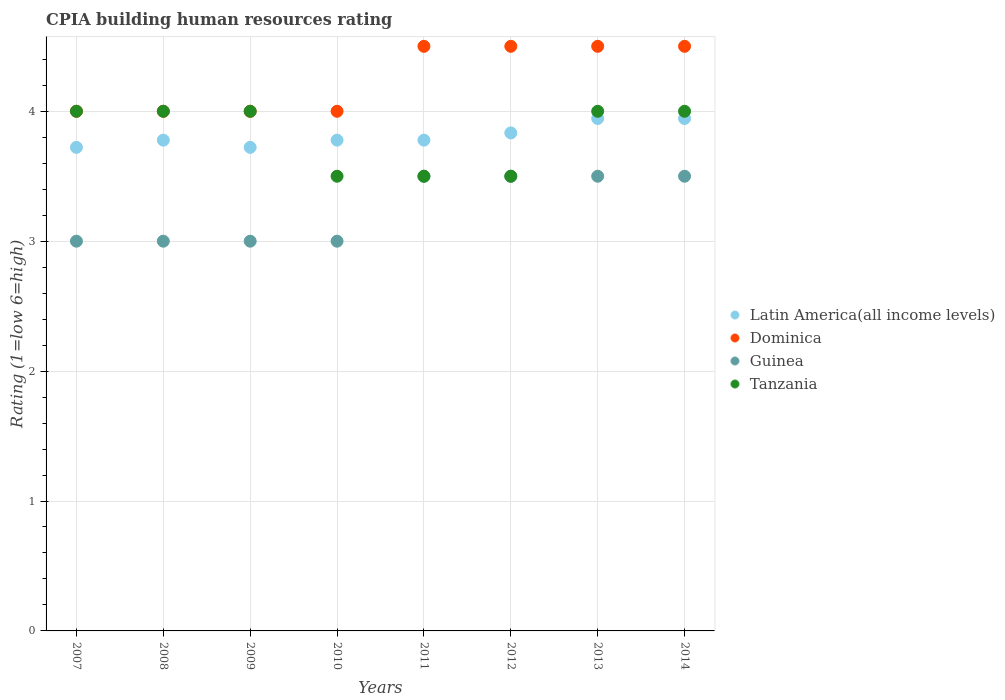How many different coloured dotlines are there?
Keep it short and to the point. 4. Is the number of dotlines equal to the number of legend labels?
Ensure brevity in your answer.  Yes. In which year was the CPIA rating in Tanzania maximum?
Your answer should be very brief. 2007. In which year was the CPIA rating in Tanzania minimum?
Your answer should be very brief. 2010. What is the total CPIA rating in Dominica in the graph?
Provide a succinct answer. 34. What is the difference between the CPIA rating in Dominica in 2008 and that in 2013?
Keep it short and to the point. -0.5. What is the difference between the CPIA rating in Latin America(all income levels) in 2014 and the CPIA rating in Guinea in 2007?
Offer a terse response. 0.94. What is the average CPIA rating in Dominica per year?
Make the answer very short. 4.25. In the year 2010, what is the difference between the CPIA rating in Tanzania and CPIA rating in Dominica?
Offer a very short reply. -0.5. In how many years, is the CPIA rating in Guinea greater than 1.2?
Your answer should be compact. 8. What is the ratio of the CPIA rating in Guinea in 2007 to that in 2014?
Make the answer very short. 0.86. Is the difference between the CPIA rating in Tanzania in 2010 and 2014 greater than the difference between the CPIA rating in Dominica in 2010 and 2014?
Ensure brevity in your answer.  No. What is the difference between the highest and the second highest CPIA rating in Dominica?
Offer a terse response. 0. What is the difference between the highest and the lowest CPIA rating in Guinea?
Keep it short and to the point. 0.5. In how many years, is the CPIA rating in Guinea greater than the average CPIA rating in Guinea taken over all years?
Your response must be concise. 4. Is the sum of the CPIA rating in Guinea in 2011 and 2014 greater than the maximum CPIA rating in Tanzania across all years?
Provide a succinct answer. Yes. Is it the case that in every year, the sum of the CPIA rating in Latin America(all income levels) and CPIA rating in Guinea  is greater than the sum of CPIA rating in Tanzania and CPIA rating in Dominica?
Your answer should be very brief. No. Is it the case that in every year, the sum of the CPIA rating in Latin America(all income levels) and CPIA rating in Dominica  is greater than the CPIA rating in Guinea?
Your answer should be compact. Yes. Does the CPIA rating in Guinea monotonically increase over the years?
Your answer should be very brief. No. Is the CPIA rating in Tanzania strictly greater than the CPIA rating in Latin America(all income levels) over the years?
Offer a terse response. No. Is the CPIA rating in Tanzania strictly less than the CPIA rating in Dominica over the years?
Offer a terse response. No. How many years are there in the graph?
Your answer should be compact. 8. Does the graph contain grids?
Offer a very short reply. Yes. How are the legend labels stacked?
Your response must be concise. Vertical. What is the title of the graph?
Your answer should be very brief. CPIA building human resources rating. Does "United States" appear as one of the legend labels in the graph?
Offer a terse response. No. What is the label or title of the Y-axis?
Provide a short and direct response. Rating (1=low 6=high). What is the Rating (1=low 6=high) of Latin America(all income levels) in 2007?
Your answer should be compact. 3.72. What is the Rating (1=low 6=high) in Dominica in 2007?
Provide a short and direct response. 4. What is the Rating (1=low 6=high) of Tanzania in 2007?
Ensure brevity in your answer.  4. What is the Rating (1=low 6=high) in Latin America(all income levels) in 2008?
Provide a short and direct response. 3.78. What is the Rating (1=low 6=high) in Latin America(all income levels) in 2009?
Your answer should be very brief. 3.72. What is the Rating (1=low 6=high) in Latin America(all income levels) in 2010?
Keep it short and to the point. 3.78. What is the Rating (1=low 6=high) of Guinea in 2010?
Give a very brief answer. 3. What is the Rating (1=low 6=high) in Tanzania in 2010?
Your answer should be very brief. 3.5. What is the Rating (1=low 6=high) of Latin America(all income levels) in 2011?
Keep it short and to the point. 3.78. What is the Rating (1=low 6=high) of Dominica in 2011?
Ensure brevity in your answer.  4.5. What is the Rating (1=low 6=high) in Guinea in 2011?
Provide a short and direct response. 3.5. What is the Rating (1=low 6=high) of Tanzania in 2011?
Give a very brief answer. 3.5. What is the Rating (1=low 6=high) of Latin America(all income levels) in 2012?
Give a very brief answer. 3.83. What is the Rating (1=low 6=high) of Dominica in 2012?
Your answer should be very brief. 4.5. What is the Rating (1=low 6=high) of Tanzania in 2012?
Ensure brevity in your answer.  3.5. What is the Rating (1=low 6=high) in Latin America(all income levels) in 2013?
Your response must be concise. 3.94. What is the Rating (1=low 6=high) of Dominica in 2013?
Offer a terse response. 4.5. What is the Rating (1=low 6=high) of Guinea in 2013?
Provide a short and direct response. 3.5. What is the Rating (1=low 6=high) in Latin America(all income levels) in 2014?
Offer a terse response. 3.94. What is the Rating (1=low 6=high) in Dominica in 2014?
Your answer should be compact. 4.5. What is the Rating (1=low 6=high) in Guinea in 2014?
Your answer should be very brief. 3.5. What is the Rating (1=low 6=high) in Tanzania in 2014?
Your answer should be very brief. 4. Across all years, what is the maximum Rating (1=low 6=high) in Latin America(all income levels)?
Your answer should be compact. 3.94. Across all years, what is the maximum Rating (1=low 6=high) in Dominica?
Your answer should be very brief. 4.5. Across all years, what is the maximum Rating (1=low 6=high) in Guinea?
Provide a succinct answer. 3.5. Across all years, what is the minimum Rating (1=low 6=high) of Latin America(all income levels)?
Your response must be concise. 3.72. Across all years, what is the minimum Rating (1=low 6=high) in Dominica?
Your response must be concise. 4. What is the total Rating (1=low 6=high) in Latin America(all income levels) in the graph?
Keep it short and to the point. 30.5. What is the total Rating (1=low 6=high) in Dominica in the graph?
Ensure brevity in your answer.  34. What is the total Rating (1=low 6=high) of Tanzania in the graph?
Provide a succinct answer. 30.5. What is the difference between the Rating (1=low 6=high) of Latin America(all income levels) in 2007 and that in 2008?
Your answer should be very brief. -0.06. What is the difference between the Rating (1=low 6=high) of Tanzania in 2007 and that in 2008?
Keep it short and to the point. 0. What is the difference between the Rating (1=low 6=high) in Dominica in 2007 and that in 2009?
Your response must be concise. 0. What is the difference between the Rating (1=low 6=high) in Guinea in 2007 and that in 2009?
Offer a terse response. 0. What is the difference between the Rating (1=low 6=high) in Tanzania in 2007 and that in 2009?
Offer a terse response. 0. What is the difference between the Rating (1=low 6=high) in Latin America(all income levels) in 2007 and that in 2010?
Provide a succinct answer. -0.06. What is the difference between the Rating (1=low 6=high) in Dominica in 2007 and that in 2010?
Your answer should be very brief. 0. What is the difference between the Rating (1=low 6=high) of Latin America(all income levels) in 2007 and that in 2011?
Give a very brief answer. -0.06. What is the difference between the Rating (1=low 6=high) in Guinea in 2007 and that in 2011?
Ensure brevity in your answer.  -0.5. What is the difference between the Rating (1=low 6=high) in Latin America(all income levels) in 2007 and that in 2012?
Your response must be concise. -0.11. What is the difference between the Rating (1=low 6=high) of Dominica in 2007 and that in 2012?
Give a very brief answer. -0.5. What is the difference between the Rating (1=low 6=high) in Latin America(all income levels) in 2007 and that in 2013?
Ensure brevity in your answer.  -0.22. What is the difference between the Rating (1=low 6=high) in Guinea in 2007 and that in 2013?
Offer a very short reply. -0.5. What is the difference between the Rating (1=low 6=high) in Tanzania in 2007 and that in 2013?
Ensure brevity in your answer.  0. What is the difference between the Rating (1=low 6=high) of Latin America(all income levels) in 2007 and that in 2014?
Keep it short and to the point. -0.22. What is the difference between the Rating (1=low 6=high) in Latin America(all income levels) in 2008 and that in 2009?
Provide a short and direct response. 0.06. What is the difference between the Rating (1=low 6=high) of Dominica in 2008 and that in 2009?
Offer a very short reply. 0. What is the difference between the Rating (1=low 6=high) in Guinea in 2008 and that in 2009?
Make the answer very short. 0. What is the difference between the Rating (1=low 6=high) in Tanzania in 2008 and that in 2009?
Offer a very short reply. 0. What is the difference between the Rating (1=low 6=high) in Latin America(all income levels) in 2008 and that in 2010?
Your answer should be very brief. 0. What is the difference between the Rating (1=low 6=high) of Guinea in 2008 and that in 2010?
Provide a short and direct response. 0. What is the difference between the Rating (1=low 6=high) of Latin America(all income levels) in 2008 and that in 2011?
Offer a terse response. 0. What is the difference between the Rating (1=low 6=high) of Dominica in 2008 and that in 2011?
Your answer should be compact. -0.5. What is the difference between the Rating (1=low 6=high) of Latin America(all income levels) in 2008 and that in 2012?
Your answer should be very brief. -0.06. What is the difference between the Rating (1=low 6=high) of Dominica in 2008 and that in 2012?
Provide a short and direct response. -0.5. What is the difference between the Rating (1=low 6=high) in Latin America(all income levels) in 2008 and that in 2013?
Offer a terse response. -0.17. What is the difference between the Rating (1=low 6=high) of Tanzania in 2008 and that in 2013?
Offer a very short reply. 0. What is the difference between the Rating (1=low 6=high) of Latin America(all income levels) in 2008 and that in 2014?
Make the answer very short. -0.17. What is the difference between the Rating (1=low 6=high) of Guinea in 2008 and that in 2014?
Provide a succinct answer. -0.5. What is the difference between the Rating (1=low 6=high) of Latin America(all income levels) in 2009 and that in 2010?
Provide a short and direct response. -0.06. What is the difference between the Rating (1=low 6=high) in Dominica in 2009 and that in 2010?
Provide a short and direct response. 0. What is the difference between the Rating (1=low 6=high) of Guinea in 2009 and that in 2010?
Your answer should be compact. 0. What is the difference between the Rating (1=low 6=high) of Tanzania in 2009 and that in 2010?
Keep it short and to the point. 0.5. What is the difference between the Rating (1=low 6=high) of Latin America(all income levels) in 2009 and that in 2011?
Give a very brief answer. -0.06. What is the difference between the Rating (1=low 6=high) of Guinea in 2009 and that in 2011?
Offer a terse response. -0.5. What is the difference between the Rating (1=low 6=high) of Tanzania in 2009 and that in 2011?
Offer a terse response. 0.5. What is the difference between the Rating (1=low 6=high) of Latin America(all income levels) in 2009 and that in 2012?
Provide a short and direct response. -0.11. What is the difference between the Rating (1=low 6=high) of Tanzania in 2009 and that in 2012?
Provide a short and direct response. 0.5. What is the difference between the Rating (1=low 6=high) of Latin America(all income levels) in 2009 and that in 2013?
Provide a succinct answer. -0.22. What is the difference between the Rating (1=low 6=high) in Latin America(all income levels) in 2009 and that in 2014?
Provide a succinct answer. -0.22. What is the difference between the Rating (1=low 6=high) in Dominica in 2009 and that in 2014?
Your answer should be compact. -0.5. What is the difference between the Rating (1=low 6=high) in Latin America(all income levels) in 2010 and that in 2011?
Offer a terse response. 0. What is the difference between the Rating (1=low 6=high) in Guinea in 2010 and that in 2011?
Give a very brief answer. -0.5. What is the difference between the Rating (1=low 6=high) of Latin America(all income levels) in 2010 and that in 2012?
Provide a succinct answer. -0.06. What is the difference between the Rating (1=low 6=high) of Guinea in 2010 and that in 2012?
Your answer should be very brief. -0.5. What is the difference between the Rating (1=low 6=high) of Tanzania in 2010 and that in 2012?
Ensure brevity in your answer.  0. What is the difference between the Rating (1=low 6=high) of Latin America(all income levels) in 2010 and that in 2013?
Give a very brief answer. -0.17. What is the difference between the Rating (1=low 6=high) in Guinea in 2010 and that in 2013?
Your answer should be compact. -0.5. What is the difference between the Rating (1=low 6=high) of Tanzania in 2010 and that in 2014?
Make the answer very short. -0.5. What is the difference between the Rating (1=low 6=high) of Latin America(all income levels) in 2011 and that in 2012?
Provide a succinct answer. -0.06. What is the difference between the Rating (1=low 6=high) of Guinea in 2011 and that in 2012?
Offer a terse response. 0. What is the difference between the Rating (1=low 6=high) in Latin America(all income levels) in 2011 and that in 2013?
Offer a terse response. -0.17. What is the difference between the Rating (1=low 6=high) of Guinea in 2011 and that in 2013?
Your answer should be compact. 0. What is the difference between the Rating (1=low 6=high) of Latin America(all income levels) in 2011 and that in 2014?
Provide a succinct answer. -0.17. What is the difference between the Rating (1=low 6=high) of Dominica in 2011 and that in 2014?
Give a very brief answer. 0. What is the difference between the Rating (1=low 6=high) in Guinea in 2011 and that in 2014?
Provide a succinct answer. 0. What is the difference between the Rating (1=low 6=high) of Tanzania in 2011 and that in 2014?
Keep it short and to the point. -0.5. What is the difference between the Rating (1=low 6=high) of Latin America(all income levels) in 2012 and that in 2013?
Provide a succinct answer. -0.11. What is the difference between the Rating (1=low 6=high) of Tanzania in 2012 and that in 2013?
Make the answer very short. -0.5. What is the difference between the Rating (1=low 6=high) of Latin America(all income levels) in 2012 and that in 2014?
Your response must be concise. -0.11. What is the difference between the Rating (1=low 6=high) in Guinea in 2012 and that in 2014?
Your response must be concise. 0. What is the difference between the Rating (1=low 6=high) of Latin America(all income levels) in 2007 and the Rating (1=low 6=high) of Dominica in 2008?
Offer a very short reply. -0.28. What is the difference between the Rating (1=low 6=high) in Latin America(all income levels) in 2007 and the Rating (1=low 6=high) in Guinea in 2008?
Provide a succinct answer. 0.72. What is the difference between the Rating (1=low 6=high) of Latin America(all income levels) in 2007 and the Rating (1=low 6=high) of Tanzania in 2008?
Give a very brief answer. -0.28. What is the difference between the Rating (1=low 6=high) in Dominica in 2007 and the Rating (1=low 6=high) in Guinea in 2008?
Your response must be concise. 1. What is the difference between the Rating (1=low 6=high) in Dominica in 2007 and the Rating (1=low 6=high) in Tanzania in 2008?
Offer a very short reply. 0. What is the difference between the Rating (1=low 6=high) in Latin America(all income levels) in 2007 and the Rating (1=low 6=high) in Dominica in 2009?
Keep it short and to the point. -0.28. What is the difference between the Rating (1=low 6=high) of Latin America(all income levels) in 2007 and the Rating (1=low 6=high) of Guinea in 2009?
Provide a succinct answer. 0.72. What is the difference between the Rating (1=low 6=high) of Latin America(all income levels) in 2007 and the Rating (1=low 6=high) of Tanzania in 2009?
Offer a very short reply. -0.28. What is the difference between the Rating (1=low 6=high) in Dominica in 2007 and the Rating (1=low 6=high) in Tanzania in 2009?
Offer a very short reply. 0. What is the difference between the Rating (1=low 6=high) of Guinea in 2007 and the Rating (1=low 6=high) of Tanzania in 2009?
Keep it short and to the point. -1. What is the difference between the Rating (1=low 6=high) of Latin America(all income levels) in 2007 and the Rating (1=low 6=high) of Dominica in 2010?
Make the answer very short. -0.28. What is the difference between the Rating (1=low 6=high) of Latin America(all income levels) in 2007 and the Rating (1=low 6=high) of Guinea in 2010?
Ensure brevity in your answer.  0.72. What is the difference between the Rating (1=low 6=high) in Latin America(all income levels) in 2007 and the Rating (1=low 6=high) in Tanzania in 2010?
Give a very brief answer. 0.22. What is the difference between the Rating (1=low 6=high) in Dominica in 2007 and the Rating (1=low 6=high) in Tanzania in 2010?
Your answer should be very brief. 0.5. What is the difference between the Rating (1=low 6=high) in Guinea in 2007 and the Rating (1=low 6=high) in Tanzania in 2010?
Keep it short and to the point. -0.5. What is the difference between the Rating (1=low 6=high) in Latin America(all income levels) in 2007 and the Rating (1=low 6=high) in Dominica in 2011?
Keep it short and to the point. -0.78. What is the difference between the Rating (1=low 6=high) of Latin America(all income levels) in 2007 and the Rating (1=low 6=high) of Guinea in 2011?
Your answer should be compact. 0.22. What is the difference between the Rating (1=low 6=high) in Latin America(all income levels) in 2007 and the Rating (1=low 6=high) in Tanzania in 2011?
Provide a succinct answer. 0.22. What is the difference between the Rating (1=low 6=high) in Dominica in 2007 and the Rating (1=low 6=high) in Guinea in 2011?
Keep it short and to the point. 0.5. What is the difference between the Rating (1=low 6=high) in Guinea in 2007 and the Rating (1=low 6=high) in Tanzania in 2011?
Provide a succinct answer. -0.5. What is the difference between the Rating (1=low 6=high) of Latin America(all income levels) in 2007 and the Rating (1=low 6=high) of Dominica in 2012?
Make the answer very short. -0.78. What is the difference between the Rating (1=low 6=high) of Latin America(all income levels) in 2007 and the Rating (1=low 6=high) of Guinea in 2012?
Your answer should be compact. 0.22. What is the difference between the Rating (1=low 6=high) of Latin America(all income levels) in 2007 and the Rating (1=low 6=high) of Tanzania in 2012?
Your answer should be very brief. 0.22. What is the difference between the Rating (1=low 6=high) of Dominica in 2007 and the Rating (1=low 6=high) of Tanzania in 2012?
Make the answer very short. 0.5. What is the difference between the Rating (1=low 6=high) in Guinea in 2007 and the Rating (1=low 6=high) in Tanzania in 2012?
Your answer should be compact. -0.5. What is the difference between the Rating (1=low 6=high) in Latin America(all income levels) in 2007 and the Rating (1=low 6=high) in Dominica in 2013?
Your answer should be compact. -0.78. What is the difference between the Rating (1=low 6=high) in Latin America(all income levels) in 2007 and the Rating (1=low 6=high) in Guinea in 2013?
Offer a terse response. 0.22. What is the difference between the Rating (1=low 6=high) of Latin America(all income levels) in 2007 and the Rating (1=low 6=high) of Tanzania in 2013?
Give a very brief answer. -0.28. What is the difference between the Rating (1=low 6=high) in Dominica in 2007 and the Rating (1=low 6=high) in Tanzania in 2013?
Keep it short and to the point. 0. What is the difference between the Rating (1=low 6=high) of Latin America(all income levels) in 2007 and the Rating (1=low 6=high) of Dominica in 2014?
Offer a terse response. -0.78. What is the difference between the Rating (1=low 6=high) in Latin America(all income levels) in 2007 and the Rating (1=low 6=high) in Guinea in 2014?
Your answer should be very brief. 0.22. What is the difference between the Rating (1=low 6=high) of Latin America(all income levels) in 2007 and the Rating (1=low 6=high) of Tanzania in 2014?
Provide a succinct answer. -0.28. What is the difference between the Rating (1=low 6=high) in Guinea in 2007 and the Rating (1=low 6=high) in Tanzania in 2014?
Offer a very short reply. -1. What is the difference between the Rating (1=low 6=high) in Latin America(all income levels) in 2008 and the Rating (1=low 6=high) in Dominica in 2009?
Give a very brief answer. -0.22. What is the difference between the Rating (1=low 6=high) of Latin America(all income levels) in 2008 and the Rating (1=low 6=high) of Tanzania in 2009?
Provide a short and direct response. -0.22. What is the difference between the Rating (1=low 6=high) of Dominica in 2008 and the Rating (1=low 6=high) of Guinea in 2009?
Your response must be concise. 1. What is the difference between the Rating (1=low 6=high) of Guinea in 2008 and the Rating (1=low 6=high) of Tanzania in 2009?
Provide a succinct answer. -1. What is the difference between the Rating (1=low 6=high) of Latin America(all income levels) in 2008 and the Rating (1=low 6=high) of Dominica in 2010?
Offer a very short reply. -0.22. What is the difference between the Rating (1=low 6=high) in Latin America(all income levels) in 2008 and the Rating (1=low 6=high) in Tanzania in 2010?
Ensure brevity in your answer.  0.28. What is the difference between the Rating (1=low 6=high) of Guinea in 2008 and the Rating (1=low 6=high) of Tanzania in 2010?
Keep it short and to the point. -0.5. What is the difference between the Rating (1=low 6=high) in Latin America(all income levels) in 2008 and the Rating (1=low 6=high) in Dominica in 2011?
Make the answer very short. -0.72. What is the difference between the Rating (1=low 6=high) of Latin America(all income levels) in 2008 and the Rating (1=low 6=high) of Guinea in 2011?
Make the answer very short. 0.28. What is the difference between the Rating (1=low 6=high) in Latin America(all income levels) in 2008 and the Rating (1=low 6=high) in Tanzania in 2011?
Your answer should be very brief. 0.28. What is the difference between the Rating (1=low 6=high) of Latin America(all income levels) in 2008 and the Rating (1=low 6=high) of Dominica in 2012?
Ensure brevity in your answer.  -0.72. What is the difference between the Rating (1=low 6=high) in Latin America(all income levels) in 2008 and the Rating (1=low 6=high) in Guinea in 2012?
Keep it short and to the point. 0.28. What is the difference between the Rating (1=low 6=high) in Latin America(all income levels) in 2008 and the Rating (1=low 6=high) in Tanzania in 2012?
Provide a succinct answer. 0.28. What is the difference between the Rating (1=low 6=high) in Dominica in 2008 and the Rating (1=low 6=high) in Guinea in 2012?
Offer a terse response. 0.5. What is the difference between the Rating (1=low 6=high) of Latin America(all income levels) in 2008 and the Rating (1=low 6=high) of Dominica in 2013?
Provide a short and direct response. -0.72. What is the difference between the Rating (1=low 6=high) in Latin America(all income levels) in 2008 and the Rating (1=low 6=high) in Guinea in 2013?
Offer a terse response. 0.28. What is the difference between the Rating (1=low 6=high) in Latin America(all income levels) in 2008 and the Rating (1=low 6=high) in Tanzania in 2013?
Ensure brevity in your answer.  -0.22. What is the difference between the Rating (1=low 6=high) in Dominica in 2008 and the Rating (1=low 6=high) in Tanzania in 2013?
Offer a terse response. 0. What is the difference between the Rating (1=low 6=high) of Guinea in 2008 and the Rating (1=low 6=high) of Tanzania in 2013?
Your answer should be compact. -1. What is the difference between the Rating (1=low 6=high) in Latin America(all income levels) in 2008 and the Rating (1=low 6=high) in Dominica in 2014?
Make the answer very short. -0.72. What is the difference between the Rating (1=low 6=high) of Latin America(all income levels) in 2008 and the Rating (1=low 6=high) of Guinea in 2014?
Your answer should be very brief. 0.28. What is the difference between the Rating (1=low 6=high) in Latin America(all income levels) in 2008 and the Rating (1=low 6=high) in Tanzania in 2014?
Your answer should be compact. -0.22. What is the difference between the Rating (1=low 6=high) of Dominica in 2008 and the Rating (1=low 6=high) of Tanzania in 2014?
Your answer should be very brief. 0. What is the difference between the Rating (1=low 6=high) of Latin America(all income levels) in 2009 and the Rating (1=low 6=high) of Dominica in 2010?
Provide a succinct answer. -0.28. What is the difference between the Rating (1=low 6=high) of Latin America(all income levels) in 2009 and the Rating (1=low 6=high) of Guinea in 2010?
Ensure brevity in your answer.  0.72. What is the difference between the Rating (1=low 6=high) of Latin America(all income levels) in 2009 and the Rating (1=low 6=high) of Tanzania in 2010?
Give a very brief answer. 0.22. What is the difference between the Rating (1=low 6=high) in Dominica in 2009 and the Rating (1=low 6=high) in Guinea in 2010?
Provide a succinct answer. 1. What is the difference between the Rating (1=low 6=high) of Guinea in 2009 and the Rating (1=low 6=high) of Tanzania in 2010?
Your response must be concise. -0.5. What is the difference between the Rating (1=low 6=high) in Latin America(all income levels) in 2009 and the Rating (1=low 6=high) in Dominica in 2011?
Offer a very short reply. -0.78. What is the difference between the Rating (1=low 6=high) in Latin America(all income levels) in 2009 and the Rating (1=low 6=high) in Guinea in 2011?
Make the answer very short. 0.22. What is the difference between the Rating (1=low 6=high) of Latin America(all income levels) in 2009 and the Rating (1=low 6=high) of Tanzania in 2011?
Provide a short and direct response. 0.22. What is the difference between the Rating (1=low 6=high) in Dominica in 2009 and the Rating (1=low 6=high) in Guinea in 2011?
Give a very brief answer. 0.5. What is the difference between the Rating (1=low 6=high) of Guinea in 2009 and the Rating (1=low 6=high) of Tanzania in 2011?
Make the answer very short. -0.5. What is the difference between the Rating (1=low 6=high) in Latin America(all income levels) in 2009 and the Rating (1=low 6=high) in Dominica in 2012?
Give a very brief answer. -0.78. What is the difference between the Rating (1=low 6=high) in Latin America(all income levels) in 2009 and the Rating (1=low 6=high) in Guinea in 2012?
Make the answer very short. 0.22. What is the difference between the Rating (1=low 6=high) of Latin America(all income levels) in 2009 and the Rating (1=low 6=high) of Tanzania in 2012?
Offer a terse response. 0.22. What is the difference between the Rating (1=low 6=high) of Dominica in 2009 and the Rating (1=low 6=high) of Guinea in 2012?
Provide a succinct answer. 0.5. What is the difference between the Rating (1=low 6=high) in Latin America(all income levels) in 2009 and the Rating (1=low 6=high) in Dominica in 2013?
Keep it short and to the point. -0.78. What is the difference between the Rating (1=low 6=high) of Latin America(all income levels) in 2009 and the Rating (1=low 6=high) of Guinea in 2013?
Give a very brief answer. 0.22. What is the difference between the Rating (1=low 6=high) in Latin America(all income levels) in 2009 and the Rating (1=low 6=high) in Tanzania in 2013?
Keep it short and to the point. -0.28. What is the difference between the Rating (1=low 6=high) in Dominica in 2009 and the Rating (1=low 6=high) in Guinea in 2013?
Ensure brevity in your answer.  0.5. What is the difference between the Rating (1=low 6=high) in Dominica in 2009 and the Rating (1=low 6=high) in Tanzania in 2013?
Make the answer very short. 0. What is the difference between the Rating (1=low 6=high) in Latin America(all income levels) in 2009 and the Rating (1=low 6=high) in Dominica in 2014?
Provide a succinct answer. -0.78. What is the difference between the Rating (1=low 6=high) in Latin America(all income levels) in 2009 and the Rating (1=low 6=high) in Guinea in 2014?
Ensure brevity in your answer.  0.22. What is the difference between the Rating (1=low 6=high) in Latin America(all income levels) in 2009 and the Rating (1=low 6=high) in Tanzania in 2014?
Provide a succinct answer. -0.28. What is the difference between the Rating (1=low 6=high) of Dominica in 2009 and the Rating (1=low 6=high) of Guinea in 2014?
Keep it short and to the point. 0.5. What is the difference between the Rating (1=low 6=high) of Dominica in 2009 and the Rating (1=low 6=high) of Tanzania in 2014?
Provide a succinct answer. 0. What is the difference between the Rating (1=low 6=high) in Guinea in 2009 and the Rating (1=low 6=high) in Tanzania in 2014?
Provide a succinct answer. -1. What is the difference between the Rating (1=low 6=high) in Latin America(all income levels) in 2010 and the Rating (1=low 6=high) in Dominica in 2011?
Offer a very short reply. -0.72. What is the difference between the Rating (1=low 6=high) in Latin America(all income levels) in 2010 and the Rating (1=low 6=high) in Guinea in 2011?
Provide a short and direct response. 0.28. What is the difference between the Rating (1=low 6=high) in Latin America(all income levels) in 2010 and the Rating (1=low 6=high) in Tanzania in 2011?
Your answer should be compact. 0.28. What is the difference between the Rating (1=low 6=high) of Dominica in 2010 and the Rating (1=low 6=high) of Tanzania in 2011?
Make the answer very short. 0.5. What is the difference between the Rating (1=low 6=high) in Latin America(all income levels) in 2010 and the Rating (1=low 6=high) in Dominica in 2012?
Provide a succinct answer. -0.72. What is the difference between the Rating (1=low 6=high) in Latin America(all income levels) in 2010 and the Rating (1=low 6=high) in Guinea in 2012?
Ensure brevity in your answer.  0.28. What is the difference between the Rating (1=low 6=high) in Latin America(all income levels) in 2010 and the Rating (1=low 6=high) in Tanzania in 2012?
Your answer should be compact. 0.28. What is the difference between the Rating (1=low 6=high) of Guinea in 2010 and the Rating (1=low 6=high) of Tanzania in 2012?
Your response must be concise. -0.5. What is the difference between the Rating (1=low 6=high) in Latin America(all income levels) in 2010 and the Rating (1=low 6=high) in Dominica in 2013?
Keep it short and to the point. -0.72. What is the difference between the Rating (1=low 6=high) in Latin America(all income levels) in 2010 and the Rating (1=low 6=high) in Guinea in 2013?
Provide a succinct answer. 0.28. What is the difference between the Rating (1=low 6=high) of Latin America(all income levels) in 2010 and the Rating (1=low 6=high) of Tanzania in 2013?
Provide a succinct answer. -0.22. What is the difference between the Rating (1=low 6=high) in Dominica in 2010 and the Rating (1=low 6=high) in Guinea in 2013?
Your response must be concise. 0.5. What is the difference between the Rating (1=low 6=high) in Dominica in 2010 and the Rating (1=low 6=high) in Tanzania in 2013?
Offer a terse response. 0. What is the difference between the Rating (1=low 6=high) in Guinea in 2010 and the Rating (1=low 6=high) in Tanzania in 2013?
Ensure brevity in your answer.  -1. What is the difference between the Rating (1=low 6=high) in Latin America(all income levels) in 2010 and the Rating (1=low 6=high) in Dominica in 2014?
Provide a succinct answer. -0.72. What is the difference between the Rating (1=low 6=high) of Latin America(all income levels) in 2010 and the Rating (1=low 6=high) of Guinea in 2014?
Keep it short and to the point. 0.28. What is the difference between the Rating (1=low 6=high) of Latin America(all income levels) in 2010 and the Rating (1=low 6=high) of Tanzania in 2014?
Provide a short and direct response. -0.22. What is the difference between the Rating (1=low 6=high) of Dominica in 2010 and the Rating (1=low 6=high) of Tanzania in 2014?
Keep it short and to the point. 0. What is the difference between the Rating (1=low 6=high) in Latin America(all income levels) in 2011 and the Rating (1=low 6=high) in Dominica in 2012?
Your answer should be very brief. -0.72. What is the difference between the Rating (1=low 6=high) in Latin America(all income levels) in 2011 and the Rating (1=low 6=high) in Guinea in 2012?
Make the answer very short. 0.28. What is the difference between the Rating (1=low 6=high) in Latin America(all income levels) in 2011 and the Rating (1=low 6=high) in Tanzania in 2012?
Provide a succinct answer. 0.28. What is the difference between the Rating (1=low 6=high) in Dominica in 2011 and the Rating (1=low 6=high) in Guinea in 2012?
Your answer should be compact. 1. What is the difference between the Rating (1=low 6=high) of Dominica in 2011 and the Rating (1=low 6=high) of Tanzania in 2012?
Offer a very short reply. 1. What is the difference between the Rating (1=low 6=high) in Guinea in 2011 and the Rating (1=low 6=high) in Tanzania in 2012?
Offer a very short reply. 0. What is the difference between the Rating (1=low 6=high) in Latin America(all income levels) in 2011 and the Rating (1=low 6=high) in Dominica in 2013?
Make the answer very short. -0.72. What is the difference between the Rating (1=low 6=high) in Latin America(all income levels) in 2011 and the Rating (1=low 6=high) in Guinea in 2013?
Your answer should be compact. 0.28. What is the difference between the Rating (1=low 6=high) of Latin America(all income levels) in 2011 and the Rating (1=low 6=high) of Tanzania in 2013?
Your answer should be compact. -0.22. What is the difference between the Rating (1=low 6=high) in Guinea in 2011 and the Rating (1=low 6=high) in Tanzania in 2013?
Provide a succinct answer. -0.5. What is the difference between the Rating (1=low 6=high) of Latin America(all income levels) in 2011 and the Rating (1=low 6=high) of Dominica in 2014?
Make the answer very short. -0.72. What is the difference between the Rating (1=low 6=high) of Latin America(all income levels) in 2011 and the Rating (1=low 6=high) of Guinea in 2014?
Offer a very short reply. 0.28. What is the difference between the Rating (1=low 6=high) of Latin America(all income levels) in 2011 and the Rating (1=low 6=high) of Tanzania in 2014?
Offer a very short reply. -0.22. What is the difference between the Rating (1=low 6=high) in Latin America(all income levels) in 2012 and the Rating (1=low 6=high) in Dominica in 2013?
Your answer should be very brief. -0.67. What is the difference between the Rating (1=low 6=high) in Latin America(all income levels) in 2012 and the Rating (1=low 6=high) in Guinea in 2013?
Make the answer very short. 0.33. What is the difference between the Rating (1=low 6=high) of Dominica in 2012 and the Rating (1=low 6=high) of Tanzania in 2013?
Your answer should be very brief. 0.5. What is the difference between the Rating (1=low 6=high) of Latin America(all income levels) in 2012 and the Rating (1=low 6=high) of Tanzania in 2014?
Provide a short and direct response. -0.17. What is the difference between the Rating (1=low 6=high) in Dominica in 2012 and the Rating (1=low 6=high) in Guinea in 2014?
Give a very brief answer. 1. What is the difference between the Rating (1=low 6=high) in Dominica in 2012 and the Rating (1=low 6=high) in Tanzania in 2014?
Your response must be concise. 0.5. What is the difference between the Rating (1=low 6=high) in Guinea in 2012 and the Rating (1=low 6=high) in Tanzania in 2014?
Offer a very short reply. -0.5. What is the difference between the Rating (1=low 6=high) in Latin America(all income levels) in 2013 and the Rating (1=low 6=high) in Dominica in 2014?
Your response must be concise. -0.56. What is the difference between the Rating (1=low 6=high) of Latin America(all income levels) in 2013 and the Rating (1=low 6=high) of Guinea in 2014?
Offer a very short reply. 0.44. What is the difference between the Rating (1=low 6=high) of Latin America(all income levels) in 2013 and the Rating (1=low 6=high) of Tanzania in 2014?
Keep it short and to the point. -0.06. What is the difference between the Rating (1=low 6=high) of Dominica in 2013 and the Rating (1=low 6=high) of Tanzania in 2014?
Offer a terse response. 0.5. What is the average Rating (1=low 6=high) in Latin America(all income levels) per year?
Provide a succinct answer. 3.81. What is the average Rating (1=low 6=high) of Dominica per year?
Give a very brief answer. 4.25. What is the average Rating (1=low 6=high) in Guinea per year?
Your answer should be very brief. 3.25. What is the average Rating (1=low 6=high) of Tanzania per year?
Keep it short and to the point. 3.81. In the year 2007, what is the difference between the Rating (1=low 6=high) of Latin America(all income levels) and Rating (1=low 6=high) of Dominica?
Your answer should be very brief. -0.28. In the year 2007, what is the difference between the Rating (1=low 6=high) of Latin America(all income levels) and Rating (1=low 6=high) of Guinea?
Keep it short and to the point. 0.72. In the year 2007, what is the difference between the Rating (1=low 6=high) in Latin America(all income levels) and Rating (1=low 6=high) in Tanzania?
Your answer should be compact. -0.28. In the year 2007, what is the difference between the Rating (1=low 6=high) of Dominica and Rating (1=low 6=high) of Guinea?
Provide a succinct answer. 1. In the year 2008, what is the difference between the Rating (1=low 6=high) in Latin America(all income levels) and Rating (1=low 6=high) in Dominica?
Your answer should be very brief. -0.22. In the year 2008, what is the difference between the Rating (1=low 6=high) in Latin America(all income levels) and Rating (1=low 6=high) in Tanzania?
Your answer should be very brief. -0.22. In the year 2008, what is the difference between the Rating (1=low 6=high) in Dominica and Rating (1=low 6=high) in Tanzania?
Provide a short and direct response. 0. In the year 2009, what is the difference between the Rating (1=low 6=high) in Latin America(all income levels) and Rating (1=low 6=high) in Dominica?
Your answer should be very brief. -0.28. In the year 2009, what is the difference between the Rating (1=low 6=high) in Latin America(all income levels) and Rating (1=low 6=high) in Guinea?
Offer a terse response. 0.72. In the year 2009, what is the difference between the Rating (1=low 6=high) of Latin America(all income levels) and Rating (1=low 6=high) of Tanzania?
Your answer should be very brief. -0.28. In the year 2009, what is the difference between the Rating (1=low 6=high) of Dominica and Rating (1=low 6=high) of Guinea?
Provide a short and direct response. 1. In the year 2009, what is the difference between the Rating (1=low 6=high) of Guinea and Rating (1=low 6=high) of Tanzania?
Ensure brevity in your answer.  -1. In the year 2010, what is the difference between the Rating (1=low 6=high) of Latin America(all income levels) and Rating (1=low 6=high) of Dominica?
Give a very brief answer. -0.22. In the year 2010, what is the difference between the Rating (1=low 6=high) in Latin America(all income levels) and Rating (1=low 6=high) in Tanzania?
Your answer should be very brief. 0.28. In the year 2011, what is the difference between the Rating (1=low 6=high) of Latin America(all income levels) and Rating (1=low 6=high) of Dominica?
Make the answer very short. -0.72. In the year 2011, what is the difference between the Rating (1=low 6=high) of Latin America(all income levels) and Rating (1=low 6=high) of Guinea?
Offer a very short reply. 0.28. In the year 2011, what is the difference between the Rating (1=low 6=high) of Latin America(all income levels) and Rating (1=low 6=high) of Tanzania?
Keep it short and to the point. 0.28. In the year 2011, what is the difference between the Rating (1=low 6=high) in Dominica and Rating (1=low 6=high) in Tanzania?
Give a very brief answer. 1. In the year 2012, what is the difference between the Rating (1=low 6=high) of Latin America(all income levels) and Rating (1=low 6=high) of Tanzania?
Keep it short and to the point. 0.33. In the year 2012, what is the difference between the Rating (1=low 6=high) of Dominica and Rating (1=low 6=high) of Tanzania?
Your response must be concise. 1. In the year 2012, what is the difference between the Rating (1=low 6=high) of Guinea and Rating (1=low 6=high) of Tanzania?
Keep it short and to the point. 0. In the year 2013, what is the difference between the Rating (1=low 6=high) of Latin America(all income levels) and Rating (1=low 6=high) of Dominica?
Make the answer very short. -0.56. In the year 2013, what is the difference between the Rating (1=low 6=high) in Latin America(all income levels) and Rating (1=low 6=high) in Guinea?
Your answer should be very brief. 0.44. In the year 2013, what is the difference between the Rating (1=low 6=high) of Latin America(all income levels) and Rating (1=low 6=high) of Tanzania?
Keep it short and to the point. -0.06. In the year 2013, what is the difference between the Rating (1=low 6=high) in Dominica and Rating (1=low 6=high) in Guinea?
Provide a succinct answer. 1. In the year 2013, what is the difference between the Rating (1=low 6=high) of Dominica and Rating (1=low 6=high) of Tanzania?
Offer a terse response. 0.5. In the year 2013, what is the difference between the Rating (1=low 6=high) in Guinea and Rating (1=low 6=high) in Tanzania?
Your response must be concise. -0.5. In the year 2014, what is the difference between the Rating (1=low 6=high) in Latin America(all income levels) and Rating (1=low 6=high) in Dominica?
Provide a succinct answer. -0.56. In the year 2014, what is the difference between the Rating (1=low 6=high) in Latin America(all income levels) and Rating (1=low 6=high) in Guinea?
Provide a short and direct response. 0.44. In the year 2014, what is the difference between the Rating (1=low 6=high) in Latin America(all income levels) and Rating (1=low 6=high) in Tanzania?
Offer a terse response. -0.06. In the year 2014, what is the difference between the Rating (1=low 6=high) in Dominica and Rating (1=low 6=high) in Tanzania?
Keep it short and to the point. 0.5. In the year 2014, what is the difference between the Rating (1=low 6=high) in Guinea and Rating (1=low 6=high) in Tanzania?
Provide a short and direct response. -0.5. What is the ratio of the Rating (1=low 6=high) in Dominica in 2007 to that in 2008?
Ensure brevity in your answer.  1. What is the ratio of the Rating (1=low 6=high) in Tanzania in 2007 to that in 2009?
Keep it short and to the point. 1. What is the ratio of the Rating (1=low 6=high) of Latin America(all income levels) in 2007 to that in 2010?
Give a very brief answer. 0.99. What is the ratio of the Rating (1=low 6=high) of Dominica in 2007 to that in 2010?
Provide a succinct answer. 1. What is the ratio of the Rating (1=low 6=high) of Tanzania in 2007 to that in 2010?
Provide a short and direct response. 1.14. What is the ratio of the Rating (1=low 6=high) in Latin America(all income levels) in 2007 to that in 2011?
Provide a short and direct response. 0.99. What is the ratio of the Rating (1=low 6=high) in Guinea in 2007 to that in 2012?
Provide a short and direct response. 0.86. What is the ratio of the Rating (1=low 6=high) in Latin America(all income levels) in 2007 to that in 2013?
Your response must be concise. 0.94. What is the ratio of the Rating (1=low 6=high) in Dominica in 2007 to that in 2013?
Offer a very short reply. 0.89. What is the ratio of the Rating (1=low 6=high) of Guinea in 2007 to that in 2013?
Your response must be concise. 0.86. What is the ratio of the Rating (1=low 6=high) in Tanzania in 2007 to that in 2013?
Offer a terse response. 1. What is the ratio of the Rating (1=low 6=high) in Latin America(all income levels) in 2007 to that in 2014?
Make the answer very short. 0.94. What is the ratio of the Rating (1=low 6=high) of Dominica in 2007 to that in 2014?
Your answer should be very brief. 0.89. What is the ratio of the Rating (1=low 6=high) in Tanzania in 2007 to that in 2014?
Your answer should be very brief. 1. What is the ratio of the Rating (1=low 6=high) of Latin America(all income levels) in 2008 to that in 2009?
Provide a succinct answer. 1.01. What is the ratio of the Rating (1=low 6=high) of Guinea in 2008 to that in 2009?
Your answer should be compact. 1. What is the ratio of the Rating (1=low 6=high) of Latin America(all income levels) in 2008 to that in 2011?
Ensure brevity in your answer.  1. What is the ratio of the Rating (1=low 6=high) of Latin America(all income levels) in 2008 to that in 2012?
Provide a succinct answer. 0.99. What is the ratio of the Rating (1=low 6=high) in Latin America(all income levels) in 2008 to that in 2013?
Give a very brief answer. 0.96. What is the ratio of the Rating (1=low 6=high) of Dominica in 2008 to that in 2013?
Give a very brief answer. 0.89. What is the ratio of the Rating (1=low 6=high) in Guinea in 2008 to that in 2013?
Provide a short and direct response. 0.86. What is the ratio of the Rating (1=low 6=high) in Latin America(all income levels) in 2008 to that in 2014?
Give a very brief answer. 0.96. What is the ratio of the Rating (1=low 6=high) of Dominica in 2008 to that in 2014?
Your response must be concise. 0.89. What is the ratio of the Rating (1=low 6=high) of Dominica in 2009 to that in 2010?
Provide a succinct answer. 1. What is the ratio of the Rating (1=low 6=high) of Guinea in 2009 to that in 2010?
Your answer should be very brief. 1. What is the ratio of the Rating (1=low 6=high) of Latin America(all income levels) in 2009 to that in 2012?
Make the answer very short. 0.97. What is the ratio of the Rating (1=low 6=high) in Latin America(all income levels) in 2009 to that in 2013?
Offer a terse response. 0.94. What is the ratio of the Rating (1=low 6=high) of Guinea in 2009 to that in 2013?
Keep it short and to the point. 0.86. What is the ratio of the Rating (1=low 6=high) of Latin America(all income levels) in 2009 to that in 2014?
Give a very brief answer. 0.94. What is the ratio of the Rating (1=low 6=high) of Dominica in 2009 to that in 2014?
Ensure brevity in your answer.  0.89. What is the ratio of the Rating (1=low 6=high) in Latin America(all income levels) in 2010 to that in 2011?
Your response must be concise. 1. What is the ratio of the Rating (1=low 6=high) in Latin America(all income levels) in 2010 to that in 2012?
Keep it short and to the point. 0.99. What is the ratio of the Rating (1=low 6=high) in Tanzania in 2010 to that in 2012?
Keep it short and to the point. 1. What is the ratio of the Rating (1=low 6=high) of Latin America(all income levels) in 2010 to that in 2013?
Provide a succinct answer. 0.96. What is the ratio of the Rating (1=low 6=high) in Dominica in 2010 to that in 2013?
Offer a terse response. 0.89. What is the ratio of the Rating (1=low 6=high) of Guinea in 2010 to that in 2013?
Give a very brief answer. 0.86. What is the ratio of the Rating (1=low 6=high) of Tanzania in 2010 to that in 2013?
Make the answer very short. 0.88. What is the ratio of the Rating (1=low 6=high) in Latin America(all income levels) in 2010 to that in 2014?
Give a very brief answer. 0.96. What is the ratio of the Rating (1=low 6=high) in Guinea in 2010 to that in 2014?
Your answer should be compact. 0.86. What is the ratio of the Rating (1=low 6=high) of Tanzania in 2010 to that in 2014?
Provide a short and direct response. 0.88. What is the ratio of the Rating (1=low 6=high) of Latin America(all income levels) in 2011 to that in 2012?
Make the answer very short. 0.99. What is the ratio of the Rating (1=low 6=high) of Dominica in 2011 to that in 2012?
Make the answer very short. 1. What is the ratio of the Rating (1=low 6=high) in Tanzania in 2011 to that in 2012?
Your answer should be compact. 1. What is the ratio of the Rating (1=low 6=high) of Latin America(all income levels) in 2011 to that in 2013?
Offer a very short reply. 0.96. What is the ratio of the Rating (1=low 6=high) of Guinea in 2011 to that in 2013?
Give a very brief answer. 1. What is the ratio of the Rating (1=low 6=high) of Latin America(all income levels) in 2011 to that in 2014?
Offer a very short reply. 0.96. What is the ratio of the Rating (1=low 6=high) in Dominica in 2011 to that in 2014?
Your answer should be compact. 1. What is the ratio of the Rating (1=low 6=high) of Latin America(all income levels) in 2012 to that in 2013?
Your answer should be compact. 0.97. What is the ratio of the Rating (1=low 6=high) in Latin America(all income levels) in 2012 to that in 2014?
Make the answer very short. 0.97. What is the ratio of the Rating (1=low 6=high) in Dominica in 2012 to that in 2014?
Give a very brief answer. 1. What is the ratio of the Rating (1=low 6=high) of Latin America(all income levels) in 2013 to that in 2014?
Provide a short and direct response. 1. What is the ratio of the Rating (1=low 6=high) of Guinea in 2013 to that in 2014?
Provide a short and direct response. 1. What is the ratio of the Rating (1=low 6=high) of Tanzania in 2013 to that in 2014?
Offer a terse response. 1. What is the difference between the highest and the second highest Rating (1=low 6=high) of Dominica?
Make the answer very short. 0. What is the difference between the highest and the second highest Rating (1=low 6=high) in Guinea?
Provide a succinct answer. 0. What is the difference between the highest and the second highest Rating (1=low 6=high) of Tanzania?
Offer a terse response. 0. What is the difference between the highest and the lowest Rating (1=low 6=high) in Latin America(all income levels)?
Make the answer very short. 0.22. What is the difference between the highest and the lowest Rating (1=low 6=high) in Guinea?
Give a very brief answer. 0.5. 